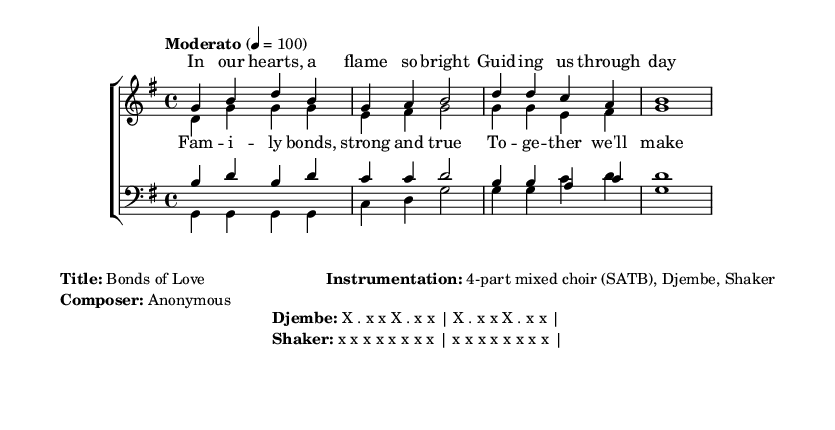What is the key signature of this music? The key signature is G major, which includes one sharp (F#). This can be identified at the beginning of the staff where the sharp is indicated.
Answer: G major What is the time signature of this music? The time signature shown is 4/4, meaning there are four beats in each measure and the quarter note gets one beat. It can be found at the beginning of the score, notated as a fraction.
Answer: 4/4 What is the tempo marking for this piece? The tempo marking indicates "Moderato" at a metronome setting of 100 beats per minute. This can be seen near the start of the score and guides the pace of the music.
Answer: Moderato How many voices are in the choir arrangement? There are four distinct vocal parts in this choral arrangement, indicated by soprano, alto, tenor, and bass voices. The score clearly assigns these categories in the staff notations at the beginning.
Answer: Four What is the theme of the lyrics in this piece? The lyrics celebrate family bonds and perseverance, which can be deduced from the text of the verse and chorus provided in the score. The lyrics emphasize unity and strength in relationships through phrases like "Family bonds, strong and true."
Answer: Family bonds What instruments accompany the choir? The accompanying instruments specified in the score are the Djembe and Shaker. This information is presented in the markup area of the score, which outlines instrumentation.
Answer: Djembe, Shaker What rhythmic pattern is used for the Djembe? The rhythmic pattern for the Djembe is represented as "X . x x X . x x," which is repeated throughout the piece. This is detailed in the markup section that describes the percussion patterns.
Answer: X . x x 